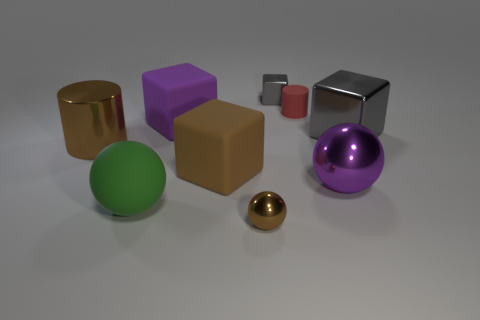Subtract all tiny metal blocks. How many blocks are left? 3 Subtract 1 balls. How many balls are left? 2 Subtract all yellow cylinders. How many gray blocks are left? 2 Add 1 large gray shiny spheres. How many objects exist? 10 Subtract all brown cubes. How many cubes are left? 3 Subtract all blue balls. Subtract all red blocks. How many balls are left? 3 Subtract all matte things. Subtract all green things. How many objects are left? 4 Add 5 big purple metal things. How many big purple metal things are left? 6 Add 4 big green rubber balls. How many big green rubber balls exist? 5 Subtract 0 purple cylinders. How many objects are left? 9 